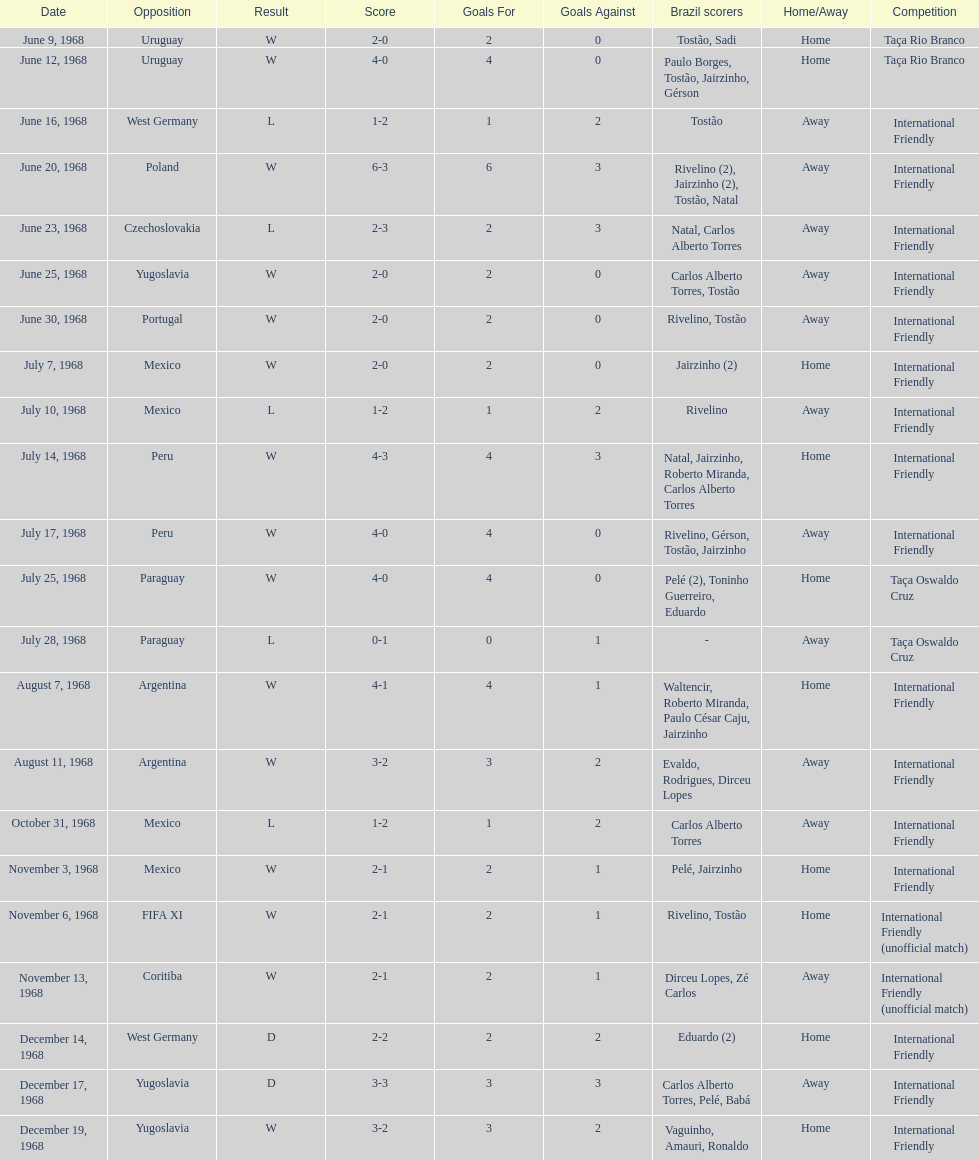How many matches are wins? 15. 